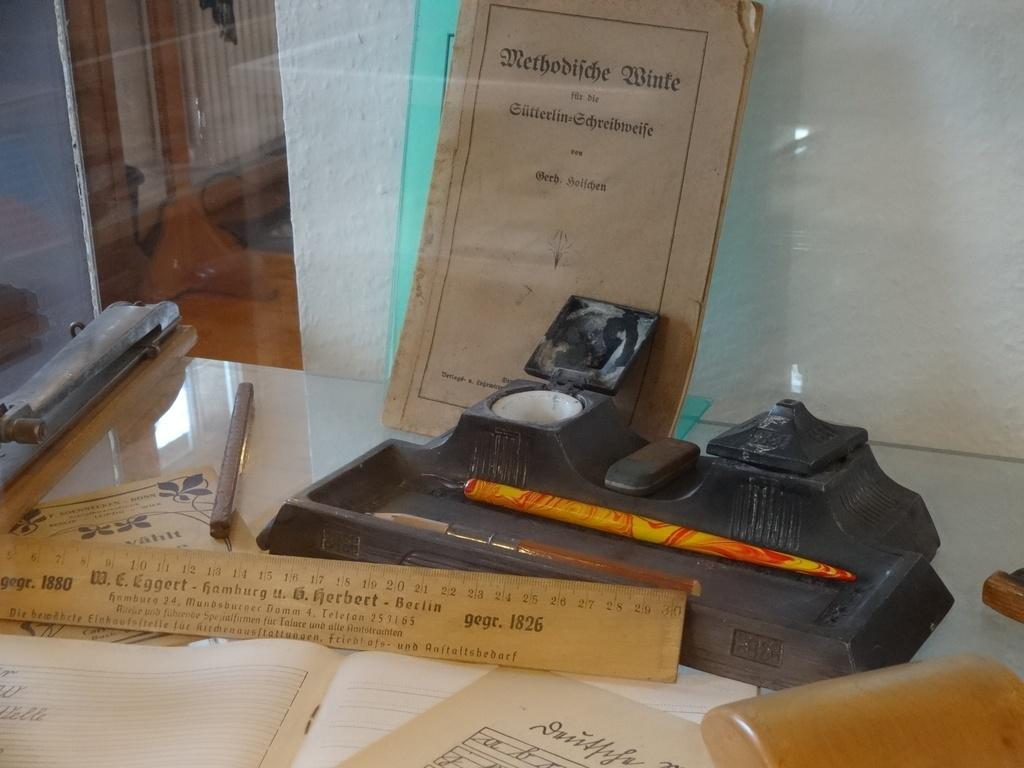<image>
Relay a brief, clear account of the picture shown. A ruler on a desk has the date 1826 on it. 